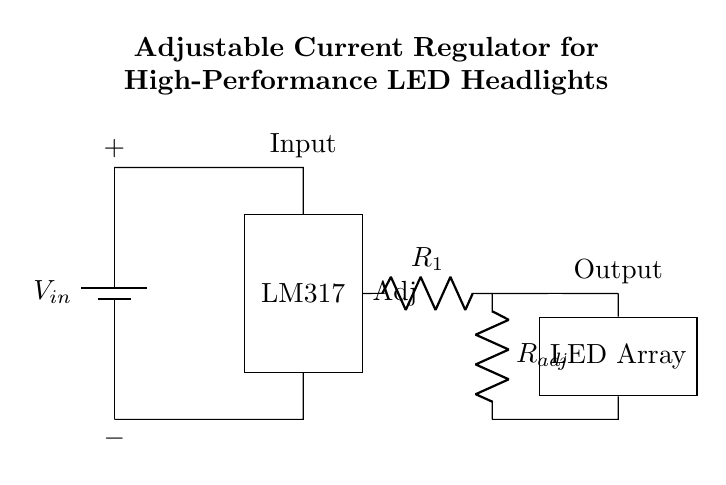What is the input voltage for this circuit? The input voltage is denoted by V_in, which is shown on the battery symbol on the left side of the diagram.
Answer: V_in What is the function of the LM317 in this circuit? The LM317 is a voltage regulator designated to control the output voltage and maintain a constant current for the LED array despite variations in input voltage or load conditions.
Answer: Voltage regulator How many resistors are present in the circuit? There are two resistors labeled as R_1 and R_adj, which are positioned on the right side of the LM317 in the circuit diagram.
Answer: Two What is the output component of this circuit? The output component is the LED Array, which is shown next to the resistors at the far right of the circuit diagram.
Answer: LED Array What type of regulator is depicted in this circuit? The circuit illustrates an adjustable current regulator because it can be fine-tuned by varying the resistance in the R_adj to set the desired current for the LED array.
Answer: Adjustable current regulator How does the adjustment resistance R_adj affect the circuit? The adjustment resistance R_adj influences the current flowing through the LED array by modifying the voltage drop across the LM317, thus allowing for adjustment of the output current delivered to the LEDs.
Answer: Adjusts output current What happens if the input voltage exceeds the LM317's maximum rating? If the input voltage exceeds the LM317's maximum rating, it could cause overheating or damage to the regulator, which may result in failure to maintain the intended output current for the LED array.
Answer: Potential damage 